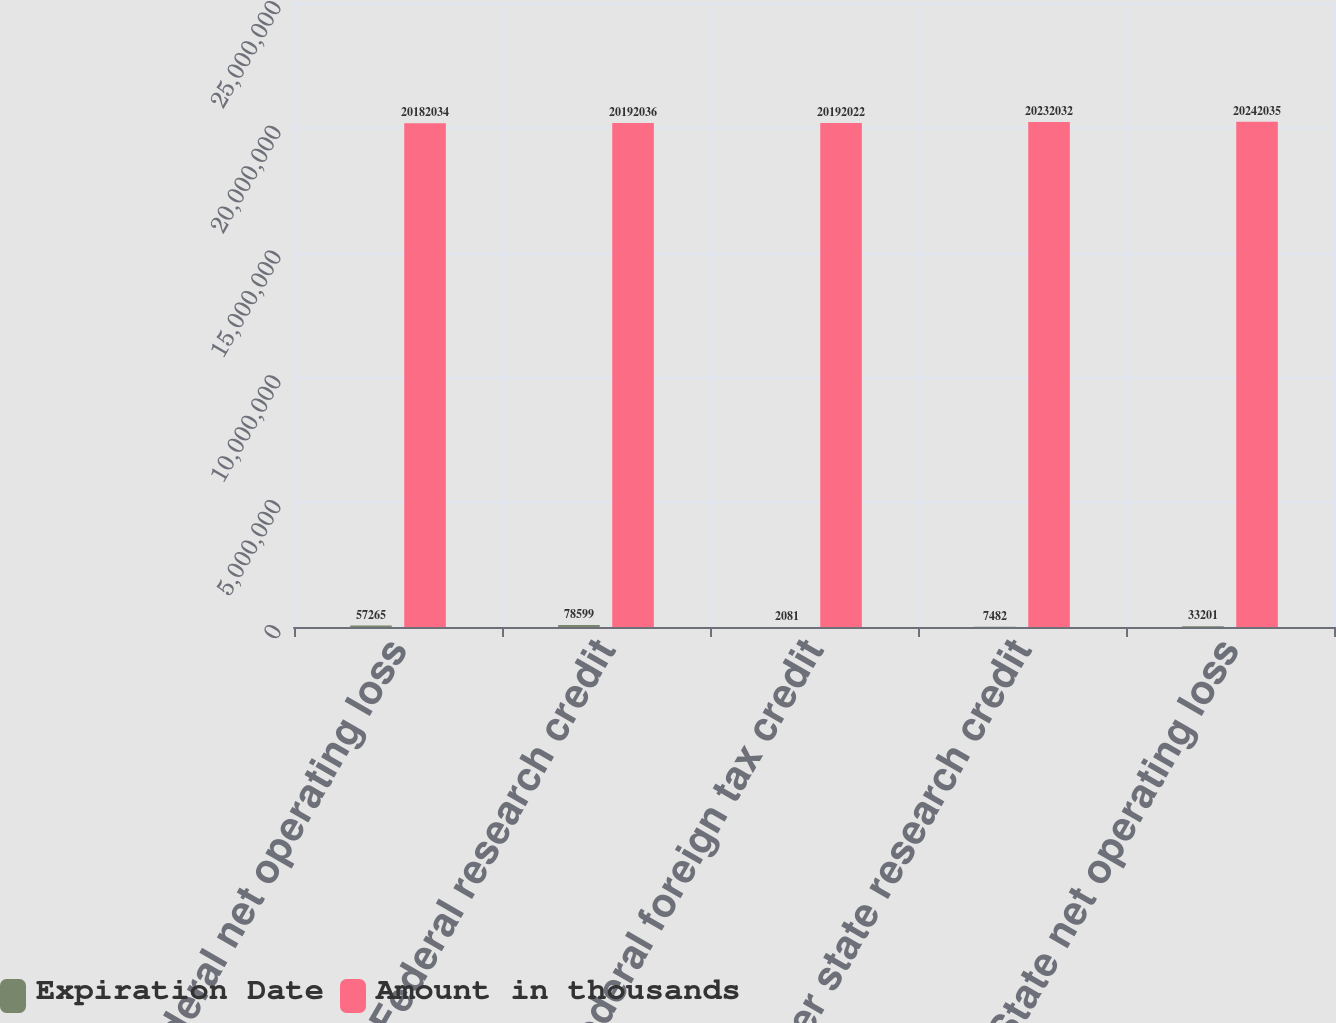Convert chart. <chart><loc_0><loc_0><loc_500><loc_500><stacked_bar_chart><ecel><fcel>Federal net operating loss<fcel>Federal research credit<fcel>Federal foreign tax credit<fcel>Other state research credit<fcel>State net operating loss<nl><fcel>Expiration Date<fcel>57265<fcel>78599<fcel>2081<fcel>7482<fcel>33201<nl><fcel>Amount in thousands<fcel>2.0182e+07<fcel>2.0192e+07<fcel>2.0192e+07<fcel>2.0232e+07<fcel>2.0242e+07<nl></chart> 